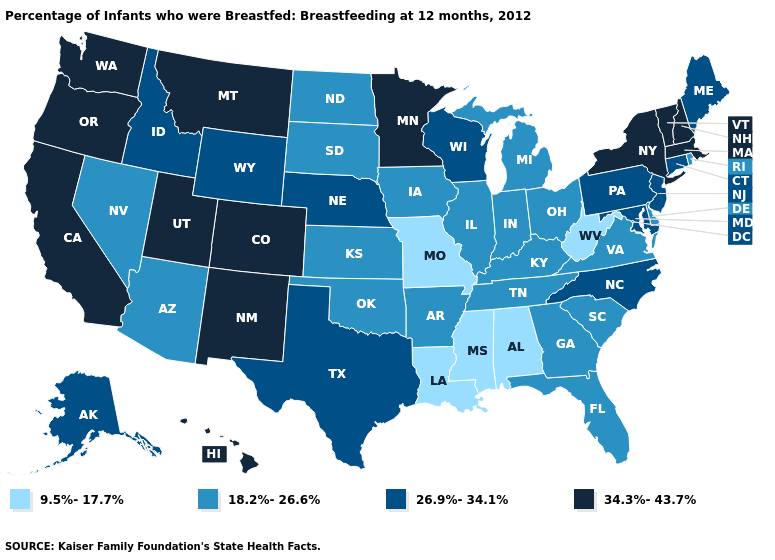Which states hav the highest value in the MidWest?
Concise answer only. Minnesota. Name the states that have a value in the range 9.5%-17.7%?
Write a very short answer. Alabama, Louisiana, Mississippi, Missouri, West Virginia. Does the map have missing data?
Short answer required. No. What is the highest value in states that border South Dakota?
Answer briefly. 34.3%-43.7%. Does New York have a higher value than Texas?
Be succinct. Yes. Name the states that have a value in the range 34.3%-43.7%?
Write a very short answer. California, Colorado, Hawaii, Massachusetts, Minnesota, Montana, New Hampshire, New Mexico, New York, Oregon, Utah, Vermont, Washington. Among the states that border New Mexico , which have the lowest value?
Keep it brief. Arizona, Oklahoma. What is the value of Maryland?
Write a very short answer. 26.9%-34.1%. What is the value of Wyoming?
Give a very brief answer. 26.9%-34.1%. Name the states that have a value in the range 18.2%-26.6%?
Short answer required. Arizona, Arkansas, Delaware, Florida, Georgia, Illinois, Indiana, Iowa, Kansas, Kentucky, Michigan, Nevada, North Dakota, Ohio, Oklahoma, Rhode Island, South Carolina, South Dakota, Tennessee, Virginia. Name the states that have a value in the range 9.5%-17.7%?
Concise answer only. Alabama, Louisiana, Mississippi, Missouri, West Virginia. Which states hav the highest value in the MidWest?
Answer briefly. Minnesota. What is the highest value in states that border Arkansas?
Quick response, please. 26.9%-34.1%. What is the value of Arkansas?
Quick response, please. 18.2%-26.6%. 